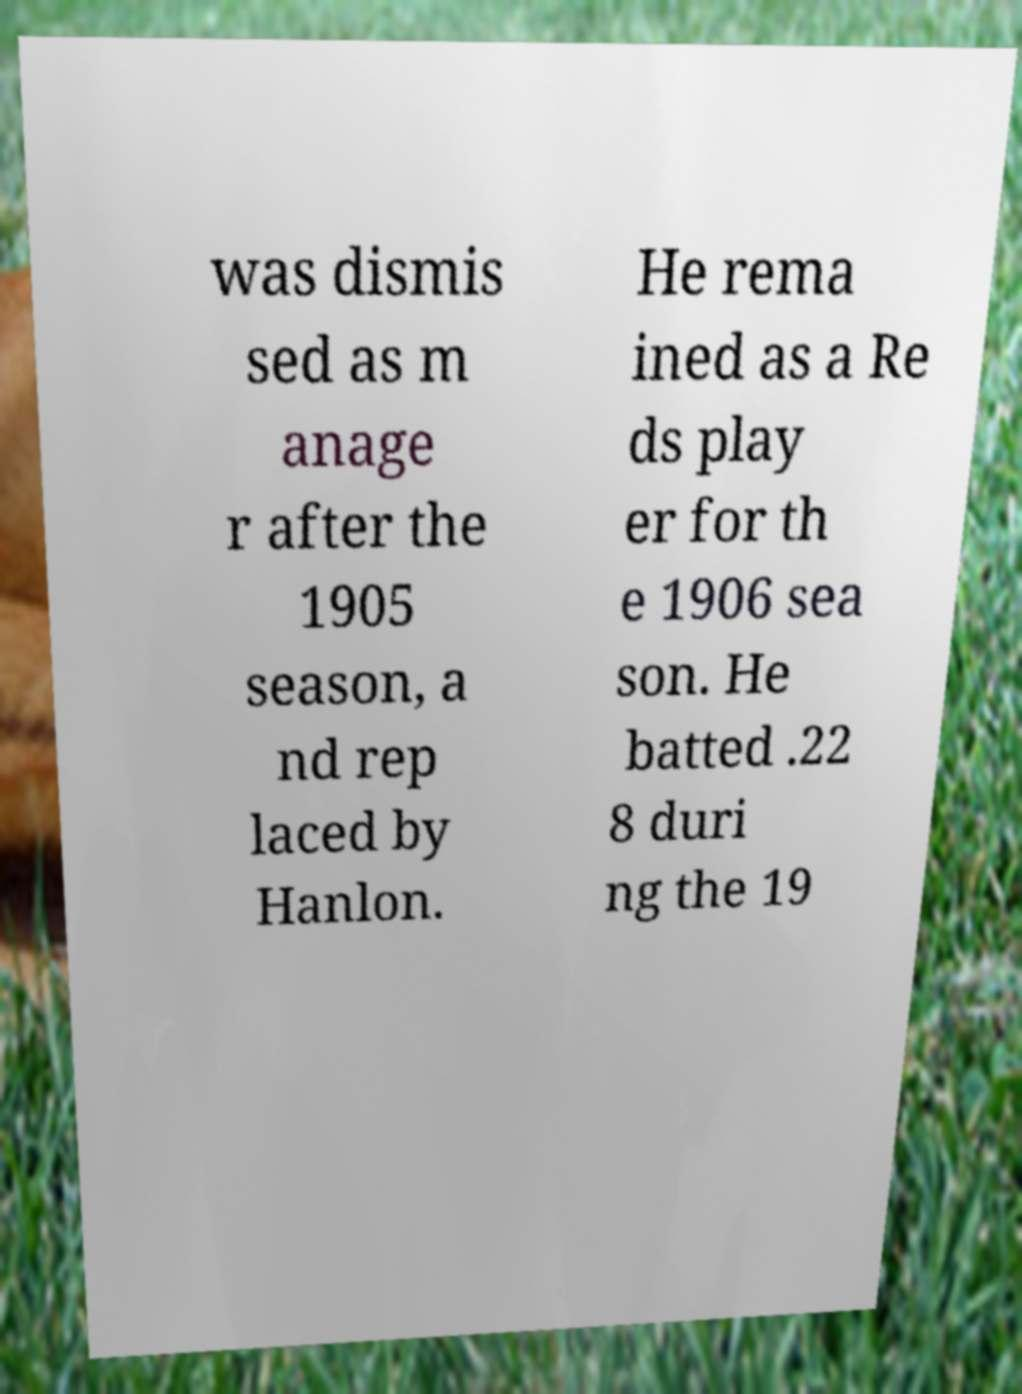Could you assist in decoding the text presented in this image and type it out clearly? was dismis sed as m anage r after the 1905 season, a nd rep laced by Hanlon. He rema ined as a Re ds play er for th e 1906 sea son. He batted .22 8 duri ng the 19 